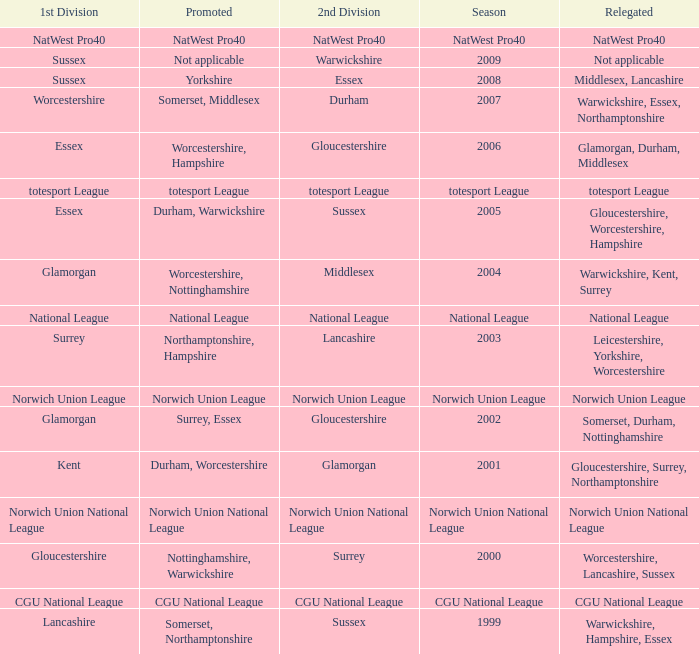What was relegated in the 2006 season? Glamorgan, Durham, Middlesex. 